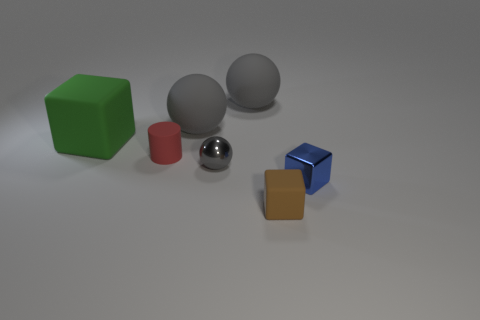How many gray spheres must be subtracted to get 2 gray spheres? 1 Subtract all rubber balls. How many balls are left? 1 Subtract all spheres. How many objects are left? 4 Subtract 3 spheres. How many spheres are left? 0 Subtract all cyan balls. How many green cylinders are left? 0 Add 1 large spheres. How many objects exist? 8 Subtract all brown cubes. How many cubes are left? 2 Subtract 1 brown cubes. How many objects are left? 6 Subtract all purple spheres. Subtract all brown blocks. How many spheres are left? 3 Subtract all tiny brown cubes. Subtract all gray rubber cylinders. How many objects are left? 6 